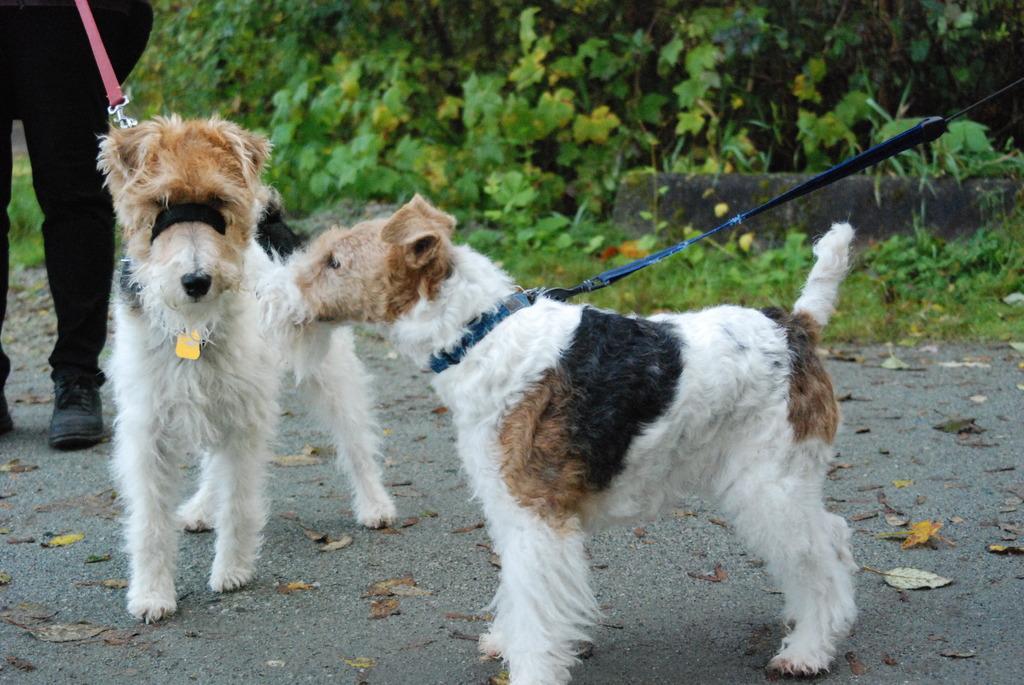How would you summarize this image in a sentence or two? In the picture I can see two dogs on the road. There is a person on the top left side though his face is not visible and he is holding the dog rope. In the background, I can see the plants. There is a green grass on the side of the road. 